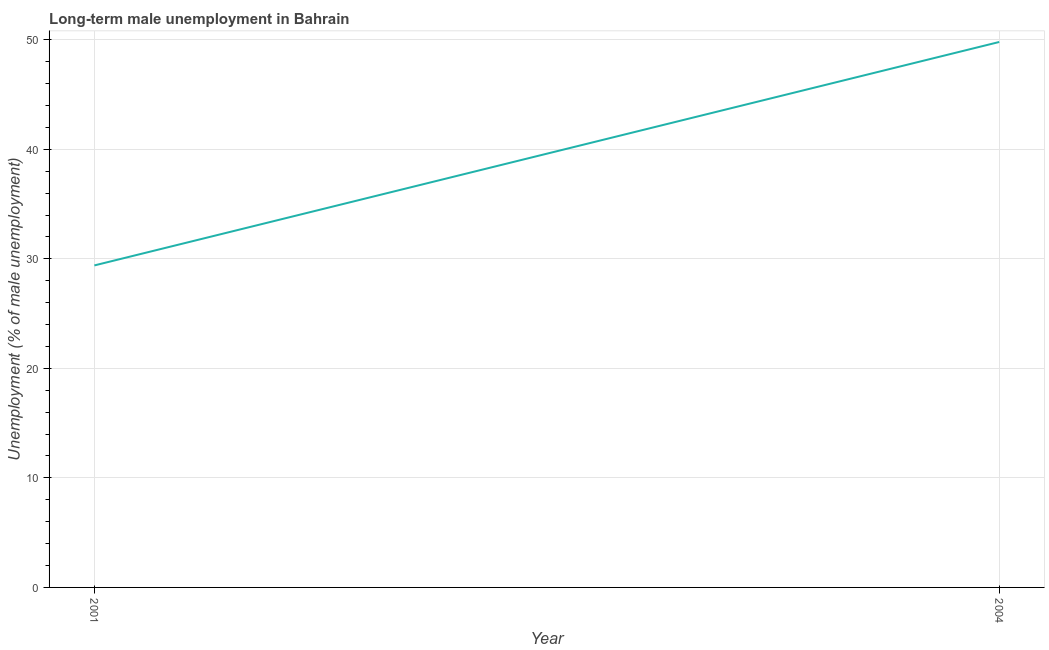What is the long-term male unemployment in 2004?
Make the answer very short. 49.8. Across all years, what is the maximum long-term male unemployment?
Your answer should be very brief. 49.8. Across all years, what is the minimum long-term male unemployment?
Provide a succinct answer. 29.4. In which year was the long-term male unemployment minimum?
Provide a short and direct response. 2001. What is the sum of the long-term male unemployment?
Ensure brevity in your answer.  79.2. What is the difference between the long-term male unemployment in 2001 and 2004?
Ensure brevity in your answer.  -20.4. What is the average long-term male unemployment per year?
Provide a short and direct response. 39.6. What is the median long-term male unemployment?
Keep it short and to the point. 39.6. In how many years, is the long-term male unemployment greater than 16 %?
Your answer should be compact. 2. What is the ratio of the long-term male unemployment in 2001 to that in 2004?
Keep it short and to the point. 0.59. Is the long-term male unemployment in 2001 less than that in 2004?
Ensure brevity in your answer.  Yes. In how many years, is the long-term male unemployment greater than the average long-term male unemployment taken over all years?
Provide a succinct answer. 1. Does the long-term male unemployment monotonically increase over the years?
Your answer should be very brief. Yes. What is the title of the graph?
Keep it short and to the point. Long-term male unemployment in Bahrain. What is the label or title of the X-axis?
Your answer should be very brief. Year. What is the label or title of the Y-axis?
Your answer should be very brief. Unemployment (% of male unemployment). What is the Unemployment (% of male unemployment) in 2001?
Your answer should be very brief. 29.4. What is the Unemployment (% of male unemployment) of 2004?
Make the answer very short. 49.8. What is the difference between the Unemployment (% of male unemployment) in 2001 and 2004?
Give a very brief answer. -20.4. What is the ratio of the Unemployment (% of male unemployment) in 2001 to that in 2004?
Provide a succinct answer. 0.59. 